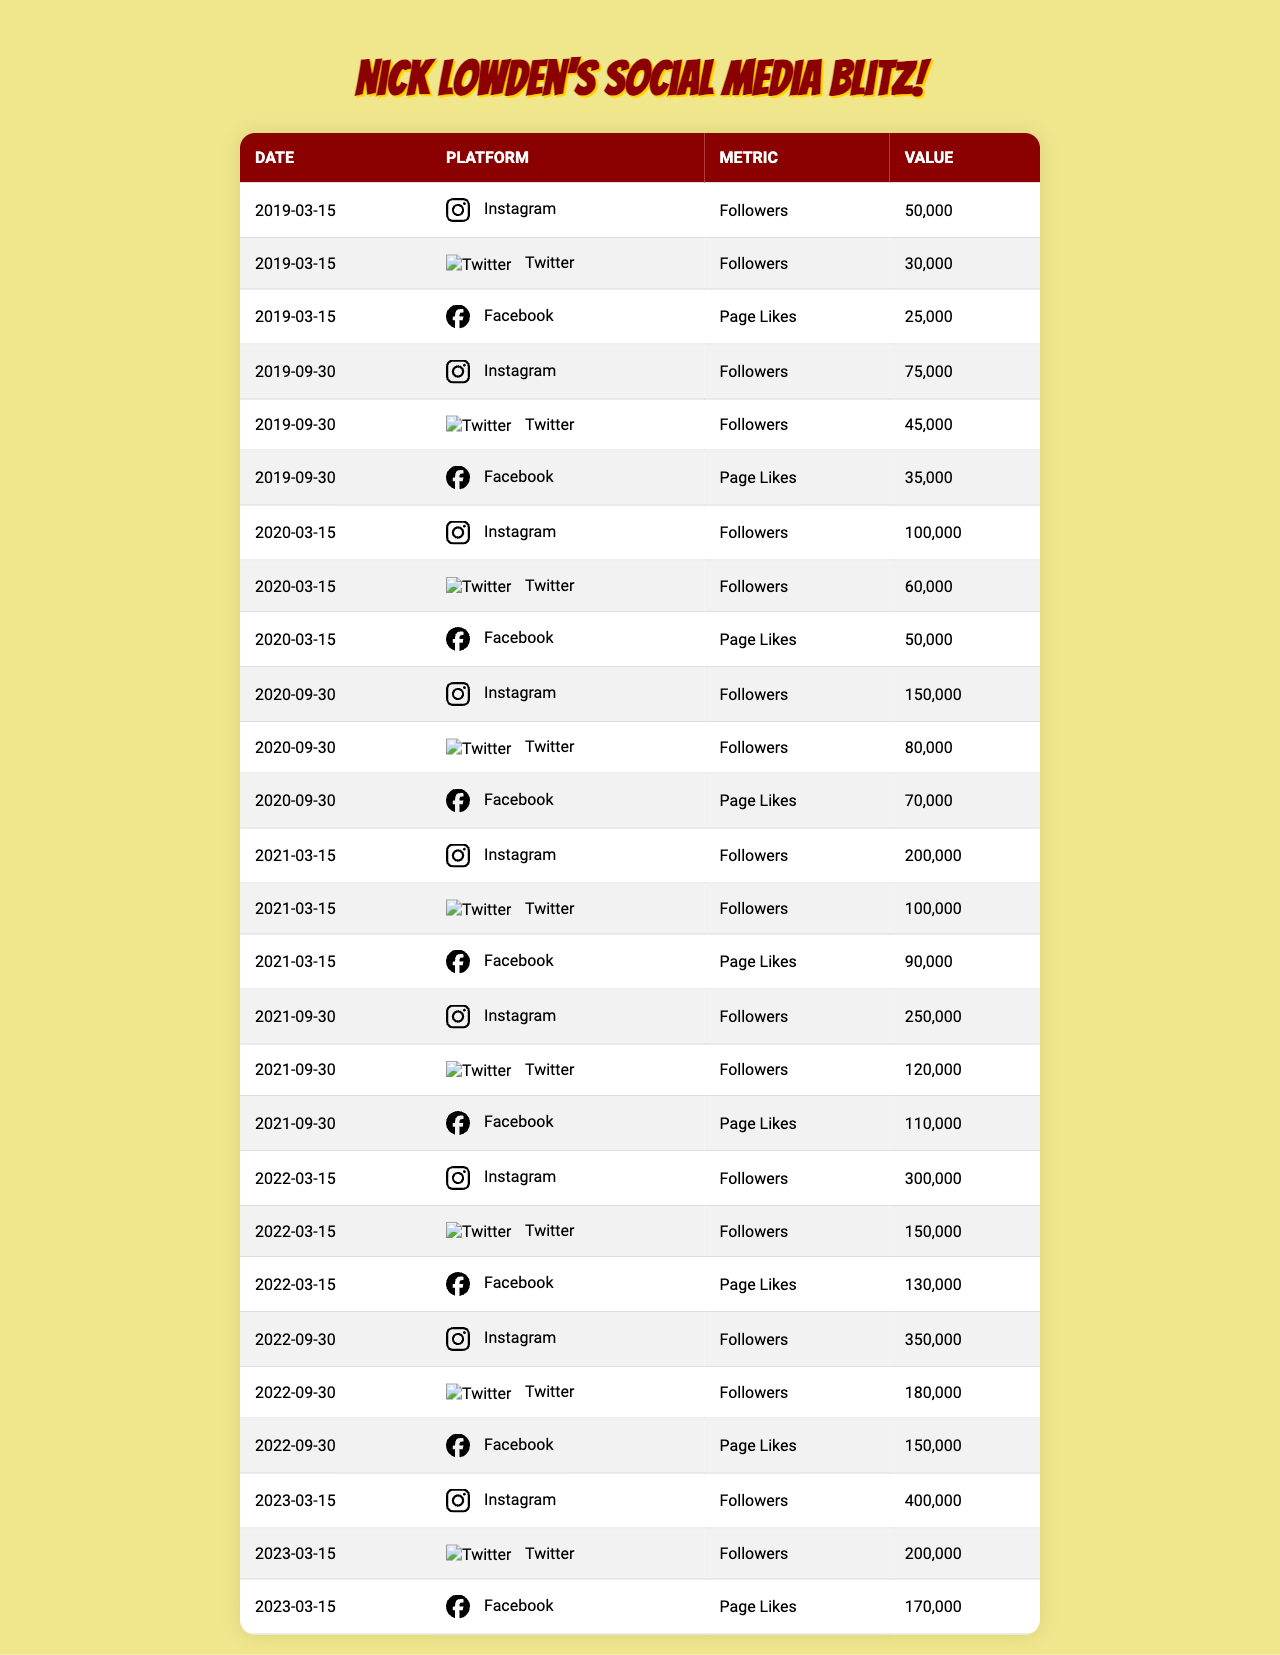What was the total number of Instagram followers for Nick Lowden as of September 30, 2021? Referring to the table, on September 30, 2021, the number of Instagram followers was 250,000.
Answer: 250,000 What was the percentage increase in Twitter followers from March 15, 2020, to September 30, 2020? On March 15, 2020, Twitter followers were 60,000 and on September 30, 2020, they increased to 80,000. The increase is 80,000 - 60,000 = 20,000. The percentage increase is (20,000 / 60,000) * 100 = 33.33%.
Answer: 33.33% Did Nick Lowden's Facebook Page Likes exceed 100,000 on any date shown in the table? Looking through the table, on March 15, 2021, Facebook Page Likes were 90,000, and on September 30, 2021, they reached 110,000. Thus, yes, they did exceed 100,000 on September 30, 2021.
Answer: Yes What is the average number of followers on Instagram over all the dates provided? The total number of Instagram followers across the provided dates (50,000 + 75,000 + 100,000 + 150,000 + 200,000 + 250,000 + 300,000 + 350,000 + 400,000) is 1,825,000. There are 9 entries, so the average followers are 1,825,000 / 9 ≈ 202,778.
Answer: 202,778 Which platform had the lowest number of followers on March 15, 2019? On March 15, 2019, Instagram had 50,000 followers, Twitter had 30,000 followers, and Facebook had 25,000 Page Likes. Comparatively, Facebook had the lowest value at 25,000.
Answer: Facebook What was the total growth in Nick Lowden's Twitter followers from March 15, 2019, to March 15, 2023? On March 15, 2019, Twitter followers were 30,000, and by March 15, 2023, they reached 200,000. The total growth is 200,000 - 30,000 = 170,000.
Answer: 170,000 How many total Page Likes did Nick Lowden have on Facebook by September 30, 2020? From the table, on September 30, 2020, the number of Page Likes on Facebook was 70,000.
Answer: 70,000 What was the largest increase in followers across all platforms from one date to the next? Analyzing the data, the largest increase occurred from March 15, 2022, to September 30, 2022, with Instagram followers increasing from 300,000 to 350,000, which is an increase of 50,000.
Answer: 50,000 Which date had the highest overall engagement across all three platforms combined? By summing values for each date, March 15, 2022, had 300,000 (Instagram) + 150,000 (Twitter) + 130,000 (Facebook) = 580,000. This was the highest compared to other dates computed similarly.
Answer: March 15, 2022 How many Facebook Page Likes did Nick Lowden have on March 15, 2022, compared to September 30, 2022? On March 15, 2022, Facebook Page Likes were 130,000, and on September 30, 2022, they increased to 150,000. Therefore, the comparison shows an improvement of 20,000 Page Likes.
Answer: 20,000 